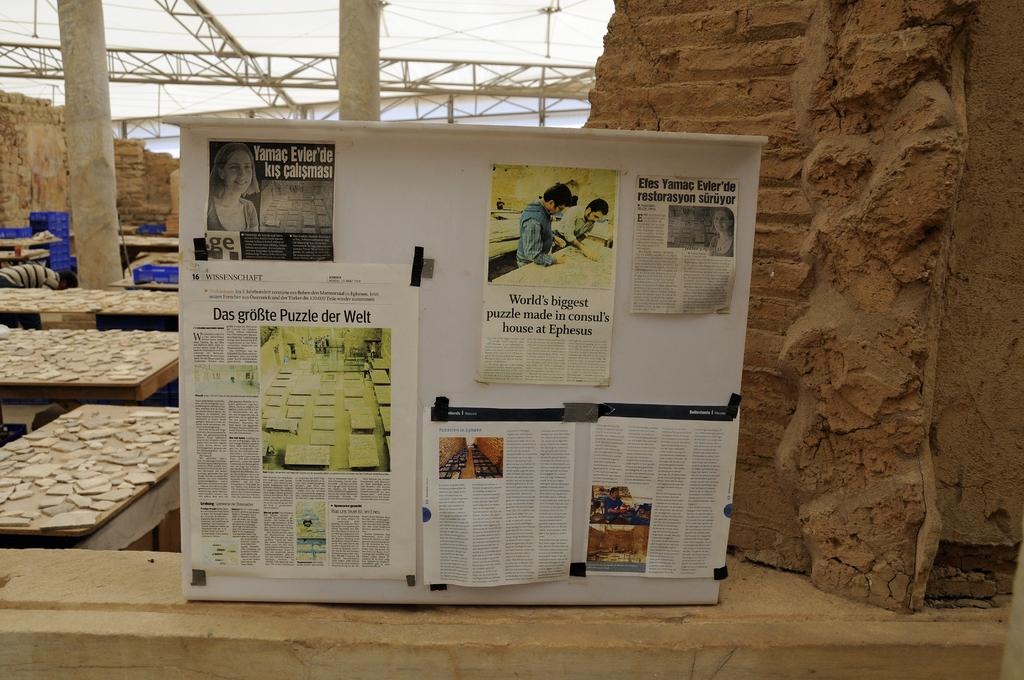<image>
Render a clear and concise summary of the photo. A magazine article about the world's biggest puzzle. 